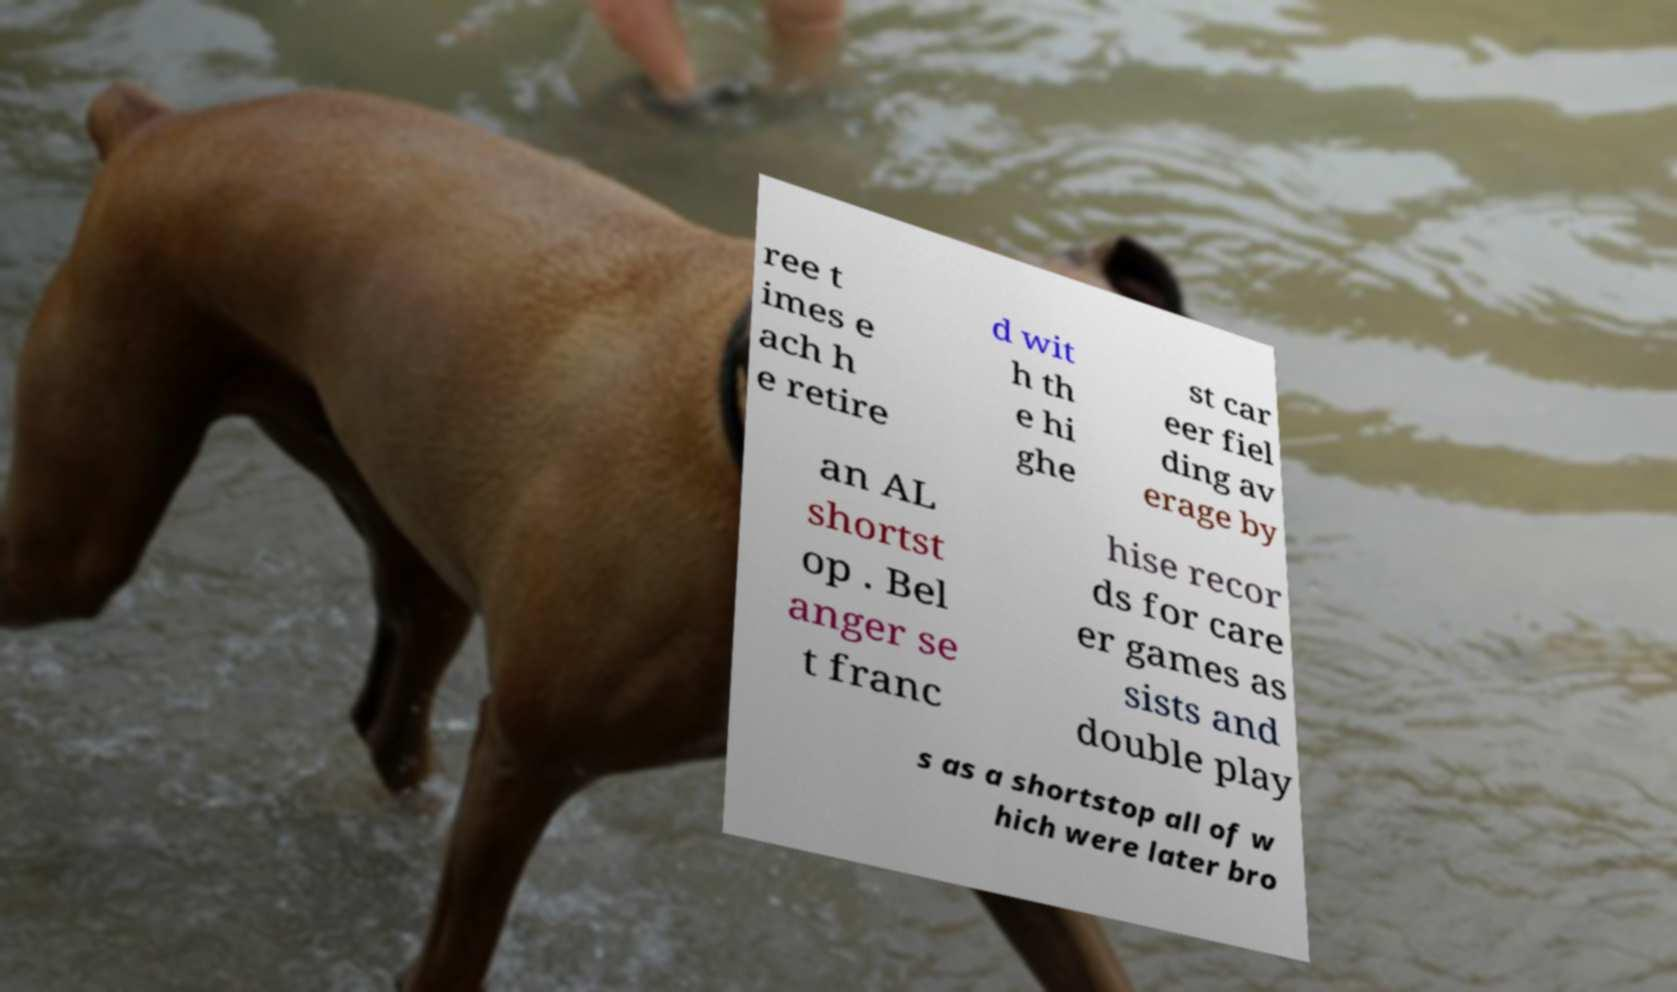Can you read and provide the text displayed in the image?This photo seems to have some interesting text. Can you extract and type it out for me? ree t imes e ach h e retire d wit h th e hi ghe st car eer fiel ding av erage by an AL shortst op . Bel anger se t franc hise recor ds for care er games as sists and double play s as a shortstop all of w hich were later bro 